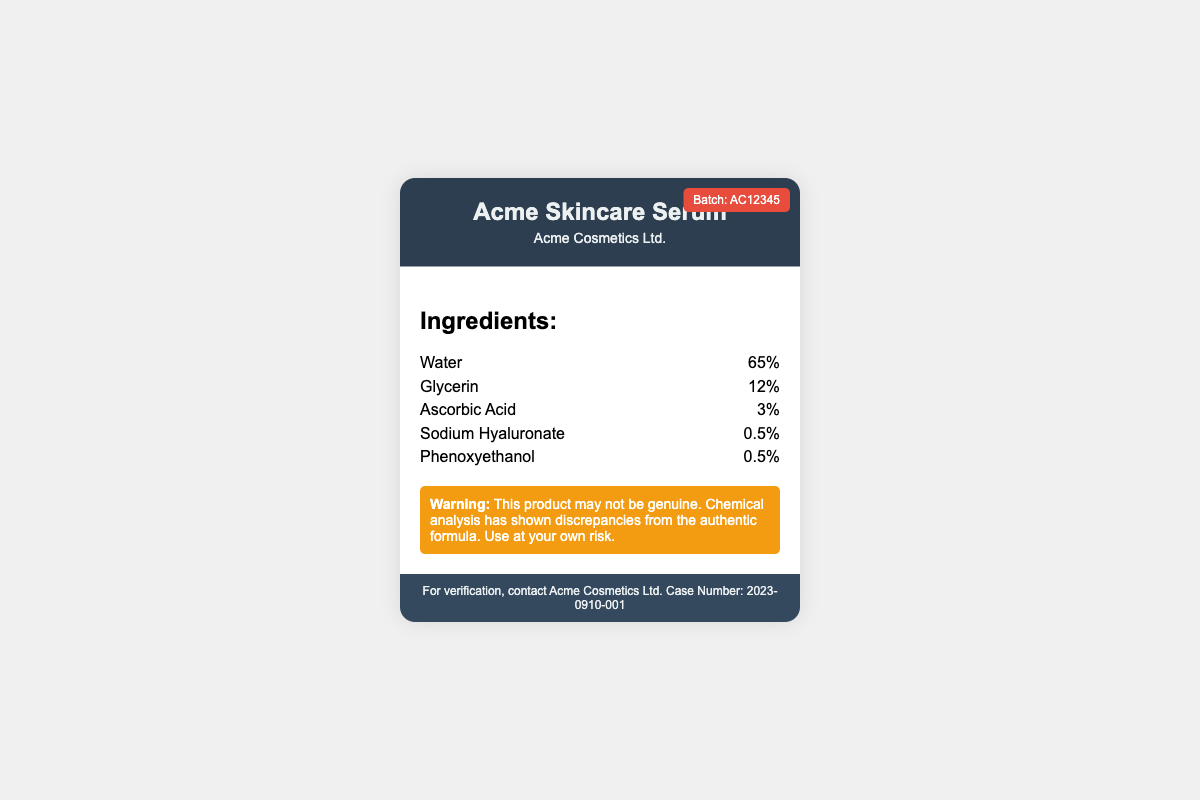what is the product name? The product name is stated prominently in the header of the document.
Answer: Acme Skincare Serum who is the manufacturer? The manufacturer is listed right below the product name in the document.
Answer: Acme Cosmetics Ltd what is the batch number? The batch number is indicated in the top right corner of the wrapper.
Answer: AC12345 what is the percentage of Glycerin in the ingredients? The percentage of each ingredient is noted adjacent to the ingredient name in the ingredients section.
Answer: 12% what is the warning about the product? The warning is highlighted in a specific section indicating the potential issues with the product.
Answer: This product may not be genuine how many ingredients are listed in the document? The number of ingredients can be counted from the ingredients section of the document.
Answer: 5 what is the total percentage of Water and Ascorbic Acid combined? The total percentage is obtained by adding the percentages of both ingredients together from their respective entries.
Answer: 68% is there a case number mentioned for verification? The footer section contains information on verification, including a case number.
Answer: 2023-0910-001 what does the presence of discrepancies imply about the product? The discrepancies suggest potential counterfeiting and pose a risk to the user.
Answer: Risk 